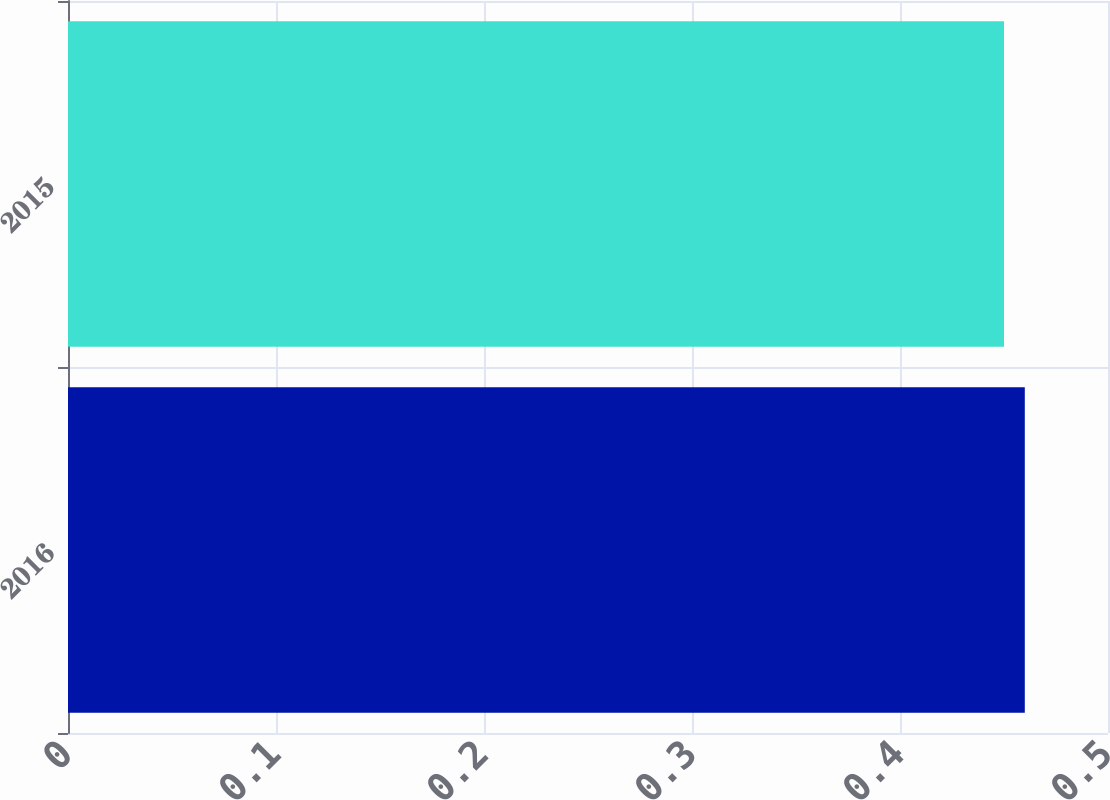Convert chart. <chart><loc_0><loc_0><loc_500><loc_500><bar_chart><fcel>2016<fcel>2015<nl><fcel>0.46<fcel>0.45<nl></chart> 